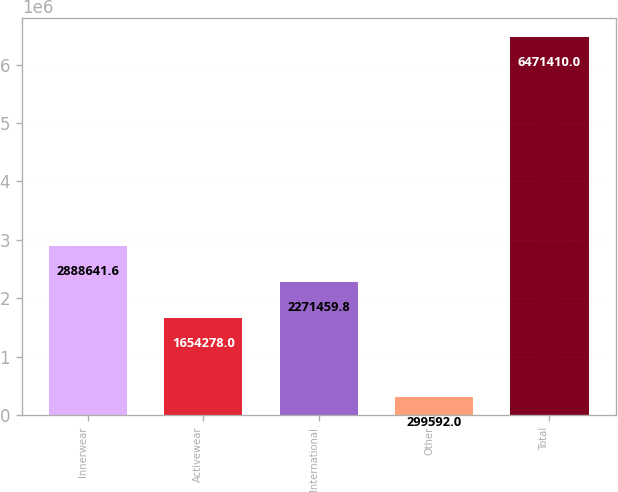<chart> <loc_0><loc_0><loc_500><loc_500><bar_chart><fcel>Innerwear<fcel>Activewear<fcel>International<fcel>Other<fcel>Total<nl><fcel>2.88864e+06<fcel>1.65428e+06<fcel>2.27146e+06<fcel>299592<fcel>6.47141e+06<nl></chart> 